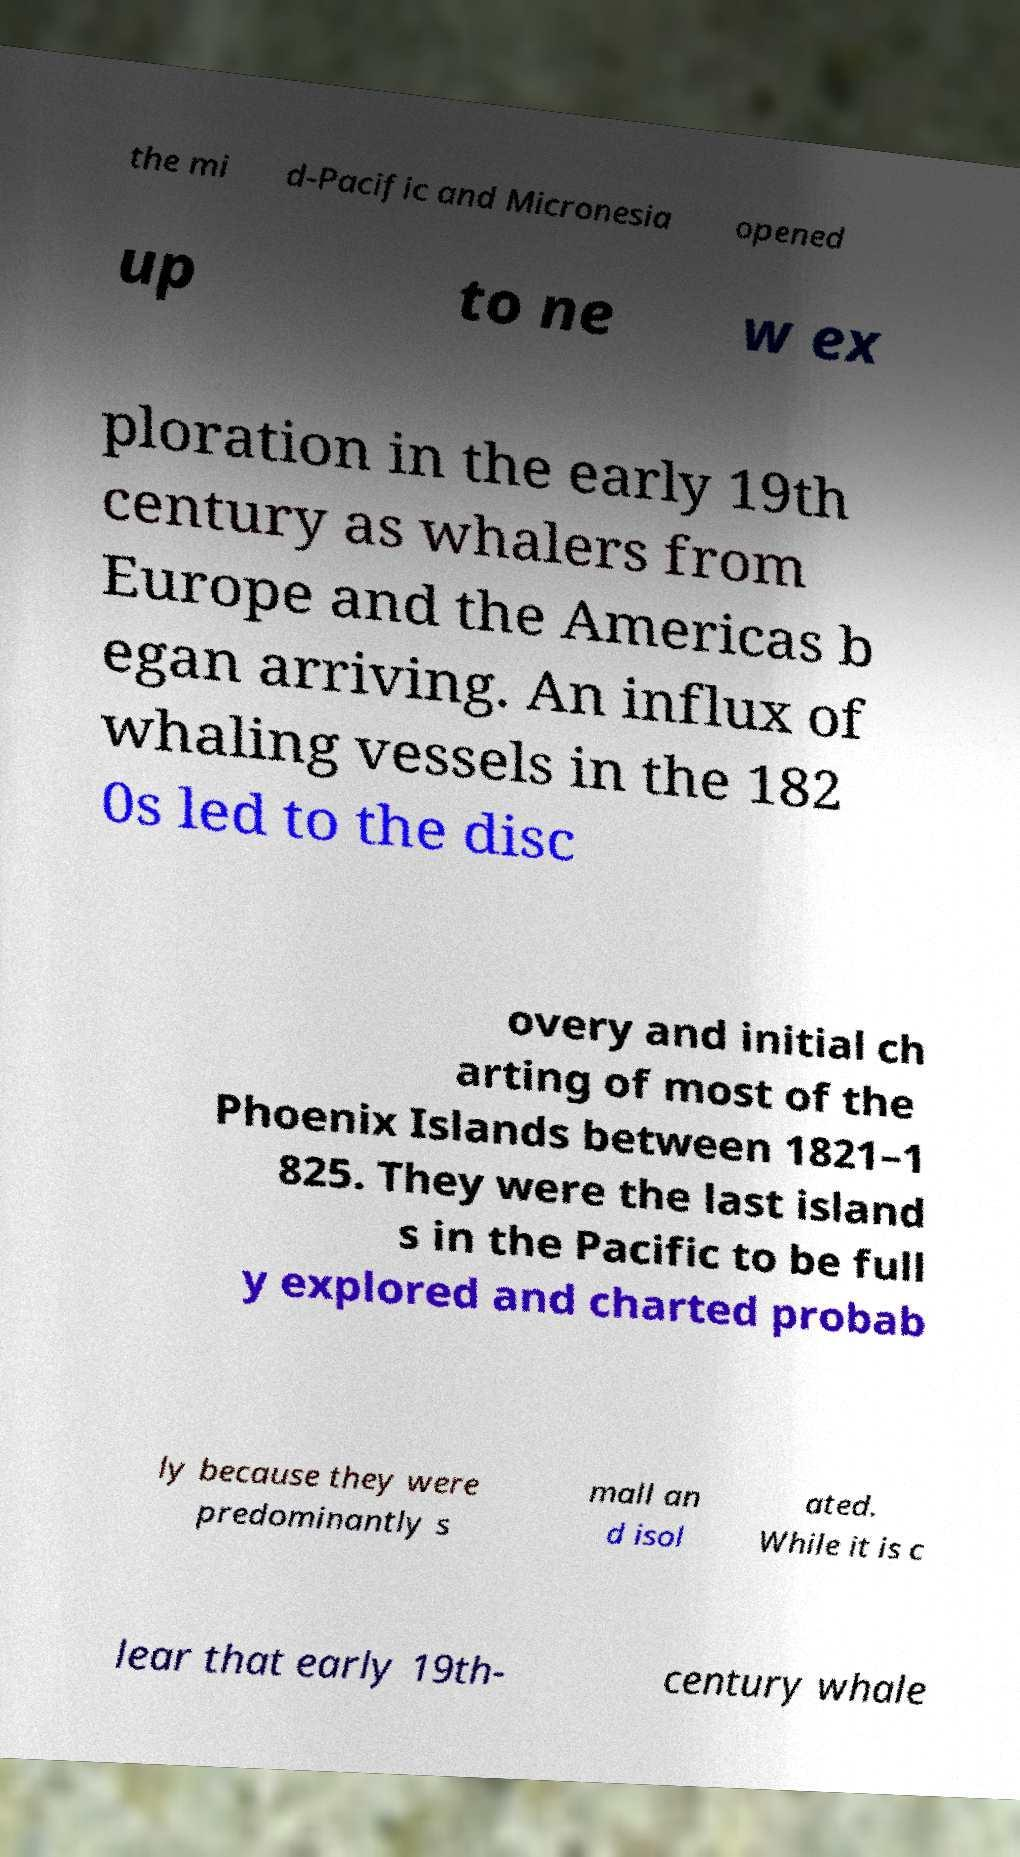Can you read and provide the text displayed in the image?This photo seems to have some interesting text. Can you extract and type it out for me? the mi d-Pacific and Micronesia opened up to ne w ex ploration in the early 19th century as whalers from Europe and the Americas b egan arriving. An influx of whaling vessels in the 182 0s led to the disc overy and initial ch arting of most of the Phoenix Islands between 1821–1 825. They were the last island s in the Pacific to be full y explored and charted probab ly because they were predominantly s mall an d isol ated. While it is c lear that early 19th- century whale 